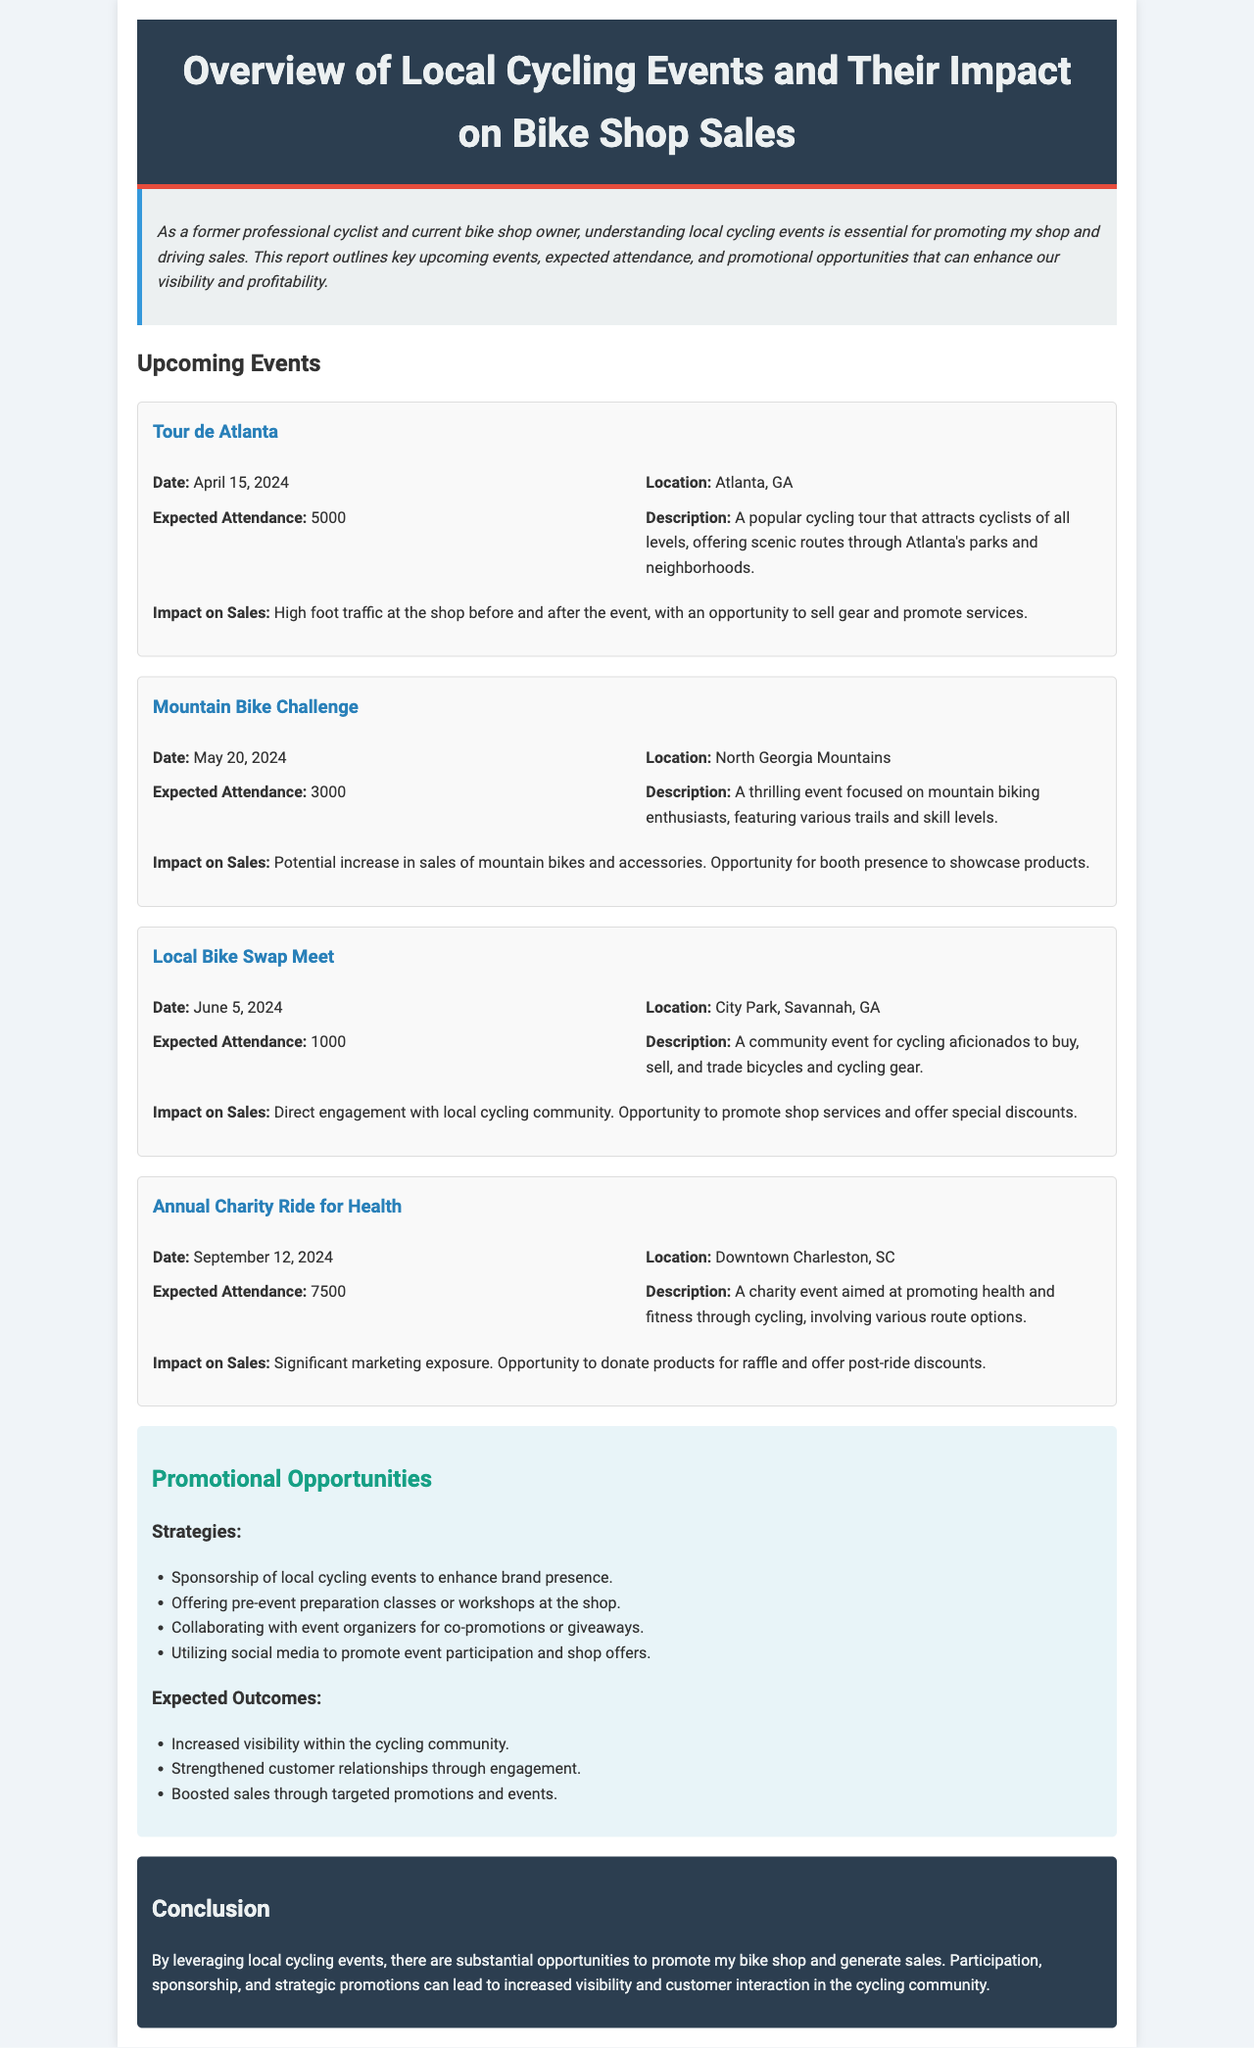What is the date of the Tour de Atlanta? The date of the Tour de Atlanta is mentioned in the document under the event details.
Answer: April 15, 2024 What is the expected attendance for the Mountain Bike Challenge? The expected attendance is provided in the event details of the Mountain Bike Challenge.
Answer: 3000 Where is the Local Bike Swap Meet taking place? The location is specified in the event details for the Local Bike Swap Meet.
Answer: City Park, Savannah, GA What impact is expected on sales during the Annual Charity Ride for Health? The document states the anticipated impact on sales in the context of the Annual Charity Ride for Health.
Answer: Significant marketing exposure What promotional strategy involves classes or workshops? The document lists promotional strategies, specifically one that includes preparation classes or workshops.
Answer: Offering pre-event preparation classes or workshops at the shop How many events are listed in the report? The total number of events can be counted from the sections that describe the events.
Answer: Four What is the primary focus of the Mountain Bike Challenge? The primary focus is described in the event's description section.
Answer: Mountain biking enthusiasts What is one expected outcome of utilizing social media for promotions? The expected outcome is detailed in the promotional opportunities section of the document.
Answer: Increased visibility within the cycling community 